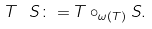<formula> <loc_0><loc_0><loc_500><loc_500>T \ S \colon = T \circ _ { \omega ( T ) } S .</formula> 